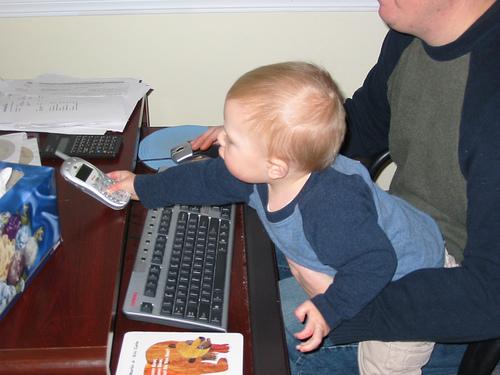What is the child reaching over?
Concise answer only. Keyboard. What gender child is here?
Short answer required. Boy. What is the child holding?
Short answer required. Cell phone. Is the baby reading a text?
Be succinct. No. 